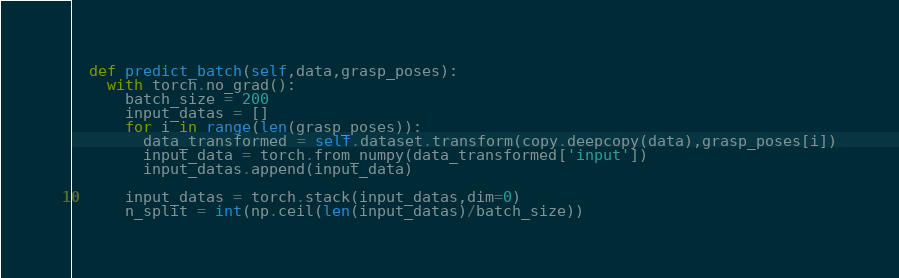Convert code to text. <code><loc_0><loc_0><loc_500><loc_500><_Python_>  def predict_batch(self,data,grasp_poses):
    with torch.no_grad():
      batch_size = 200
      input_datas = []
      for i in range(len(grasp_poses)):
        data_transformed = self.dataset.transform(copy.deepcopy(data),grasp_poses[i])
        input_data = torch.from_numpy(data_transformed['input'])
        input_datas.append(input_data)

      input_datas = torch.stack(input_datas,dim=0)
      n_split = int(np.ceil(len(input_datas)/batch_size))</code> 